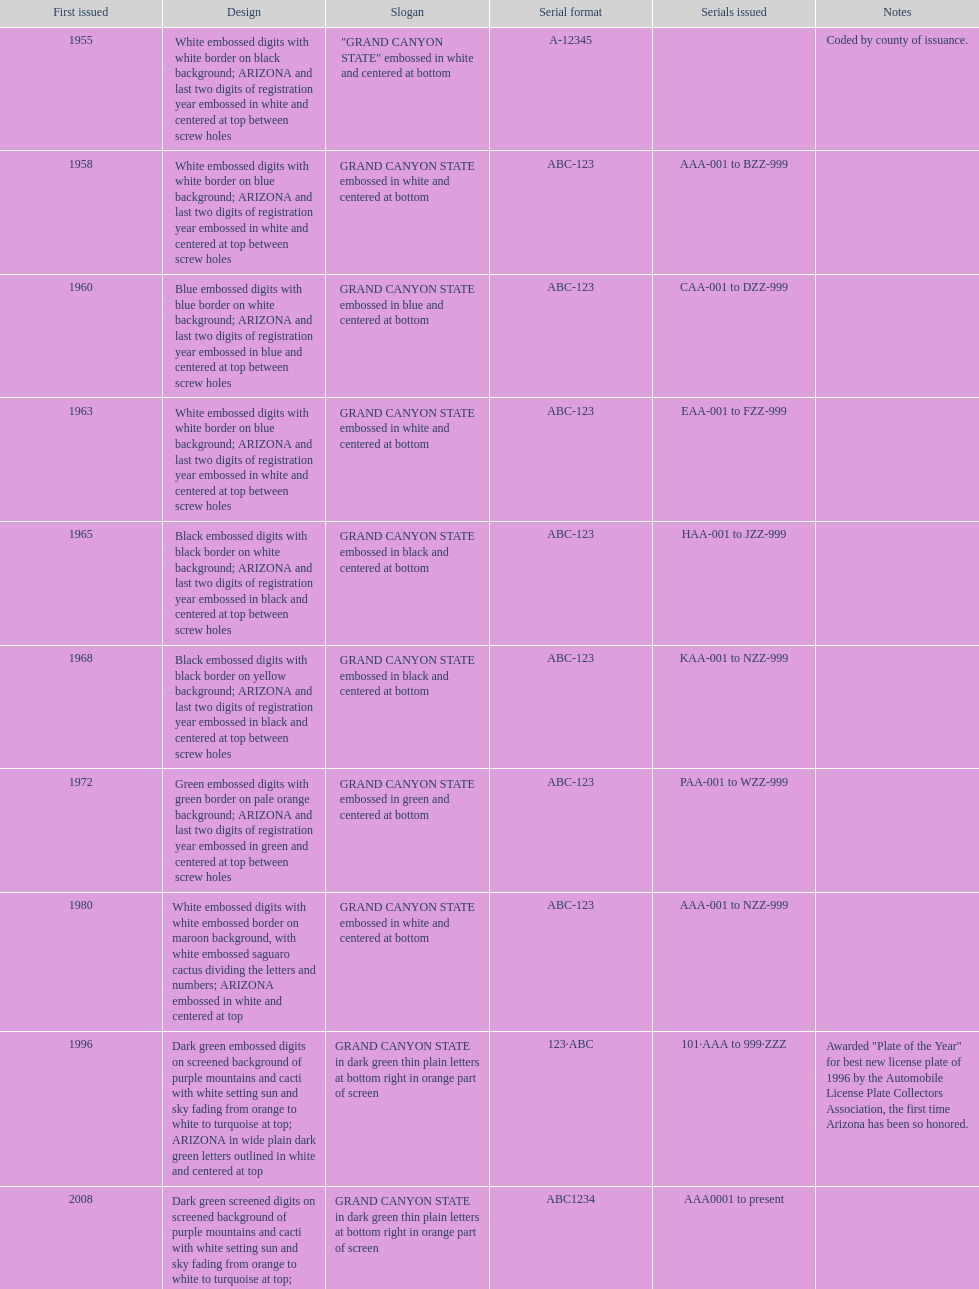Would you mind parsing the complete table? {'header': ['First issued', 'Design', 'Slogan', 'Serial format', 'Serials issued', 'Notes'], 'rows': [['1955', 'White embossed digits with white border on black background; ARIZONA and last two digits of registration year embossed in white and centered at top between screw holes', '"GRAND CANYON STATE" embossed in white and centered at bottom', 'A-12345', '', 'Coded by county of issuance.'], ['1958', 'White embossed digits with white border on blue background; ARIZONA and last two digits of registration year embossed in white and centered at top between screw holes', 'GRAND CANYON STATE embossed in white and centered at bottom', 'ABC-123', 'AAA-001 to BZZ-999', ''], ['1960', 'Blue embossed digits with blue border on white background; ARIZONA and last two digits of registration year embossed in blue and centered at top between screw holes', 'GRAND CANYON STATE embossed in blue and centered at bottom', 'ABC-123', 'CAA-001 to DZZ-999', ''], ['1963', 'White embossed digits with white border on blue background; ARIZONA and last two digits of registration year embossed in white and centered at top between screw holes', 'GRAND CANYON STATE embossed in white and centered at bottom', 'ABC-123', 'EAA-001 to FZZ-999', ''], ['1965', 'Black embossed digits with black border on white background; ARIZONA and last two digits of registration year embossed in black and centered at top between screw holes', 'GRAND CANYON STATE embossed in black and centered at bottom', 'ABC-123', 'HAA-001 to JZZ-999', ''], ['1968', 'Black embossed digits with black border on yellow background; ARIZONA and last two digits of registration year embossed in black and centered at top between screw holes', 'GRAND CANYON STATE embossed in black and centered at bottom', 'ABC-123', 'KAA-001 to NZZ-999', ''], ['1972', 'Green embossed digits with green border on pale orange background; ARIZONA and last two digits of registration year embossed in green and centered at top between screw holes', 'GRAND CANYON STATE embossed in green and centered at bottom', 'ABC-123', 'PAA-001 to WZZ-999', ''], ['1980', 'White embossed digits with white embossed border on maroon background, with white embossed saguaro cactus dividing the letters and numbers; ARIZONA embossed in white and centered at top', 'GRAND CANYON STATE embossed in white and centered at bottom', 'ABC-123', 'AAA-001 to NZZ-999', ''], ['1996', 'Dark green embossed digits on screened background of purple mountains and cacti with white setting sun and sky fading from orange to white to turquoise at top; ARIZONA in wide plain dark green letters outlined in white and centered at top', 'GRAND CANYON STATE in dark green thin plain letters at bottom right in orange part of screen', '123·ABC', '101·AAA to 999·ZZZ', 'Awarded "Plate of the Year" for best new license plate of 1996 by the Automobile License Plate Collectors Association, the first time Arizona has been so honored.'], ['2008', 'Dark green screened digits on screened background of purple mountains and cacti with white setting sun and sky fading from orange to white to turquoise at top; ARIZONA in wide plain dark green letters outlined in white and centered at top; security stripe through center of plate', 'GRAND CANYON STATE in dark green thin plain letters at bottom right in orange part of screen', 'ABC1234', 'AAA0001 to present', '']]} What is the standard serial arrangement of the arizona license plates? ABC-123. 